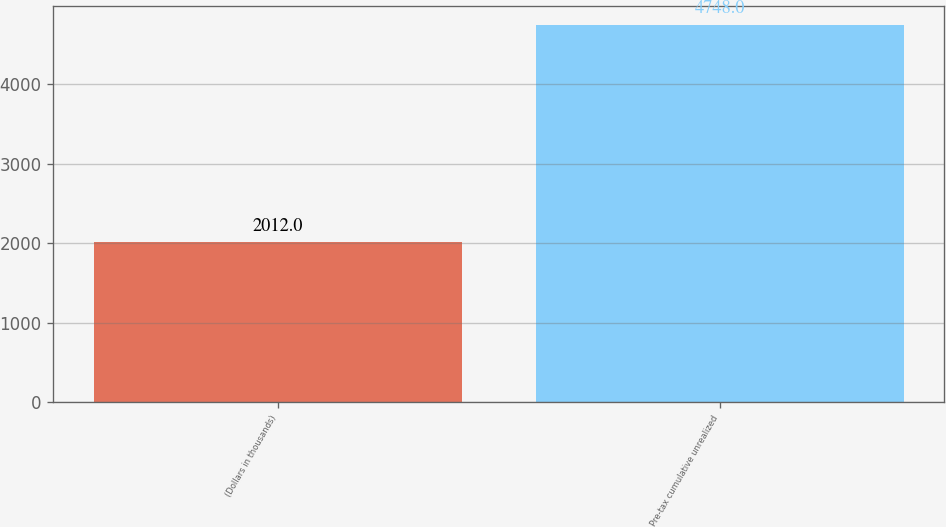<chart> <loc_0><loc_0><loc_500><loc_500><bar_chart><fcel>(Dollars in thousands)<fcel>Pre-tax cumulative unrealized<nl><fcel>2012<fcel>4748<nl></chart> 